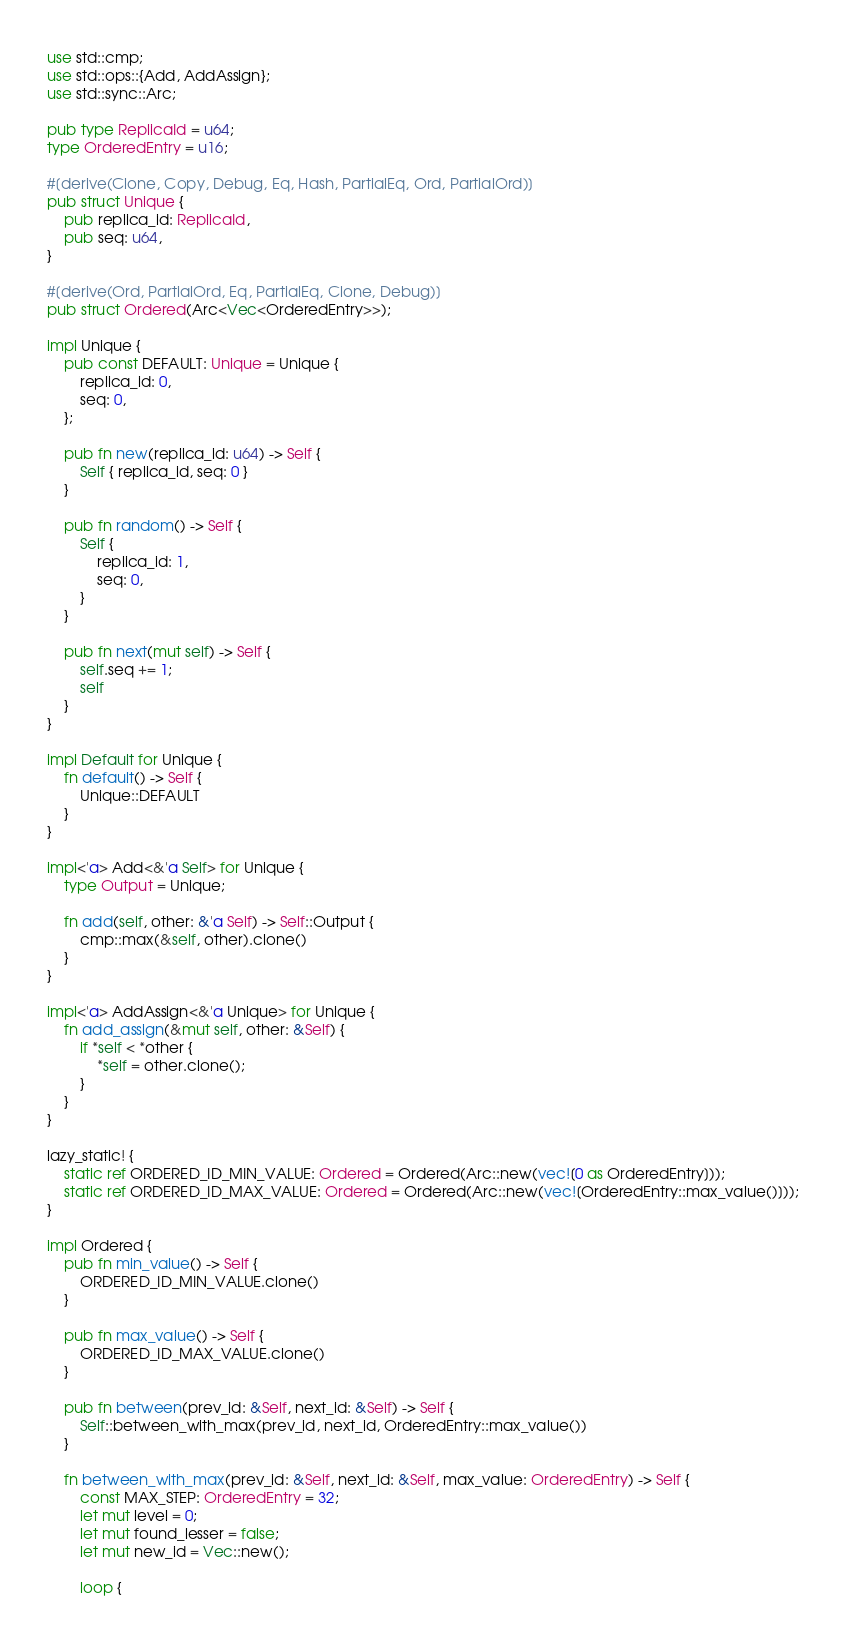<code> <loc_0><loc_0><loc_500><loc_500><_Rust_>use std::cmp;
use std::ops::{Add, AddAssign};
use std::sync::Arc;

pub type ReplicaId = u64;
type OrderedEntry = u16;

#[derive(Clone, Copy, Debug, Eq, Hash, PartialEq, Ord, PartialOrd)]
pub struct Unique {
    pub replica_id: ReplicaId,
    pub seq: u64,
}

#[derive(Ord, PartialOrd, Eq, PartialEq, Clone, Debug)]
pub struct Ordered(Arc<Vec<OrderedEntry>>);

impl Unique {
    pub const DEFAULT: Unique = Unique {
        replica_id: 0,
        seq: 0,
    };

    pub fn new(replica_id: u64) -> Self {
        Self { replica_id, seq: 0 }
    }

    pub fn random() -> Self {
        Self {
            replica_id: 1,
            seq: 0,
        }
    }

    pub fn next(mut self) -> Self {
        self.seq += 1;
        self
    }
}

impl Default for Unique {
    fn default() -> Self {
        Unique::DEFAULT
    }
}

impl<'a> Add<&'a Self> for Unique {
    type Output = Unique;

    fn add(self, other: &'a Self) -> Self::Output {
        cmp::max(&self, other).clone()
    }
}

impl<'a> AddAssign<&'a Unique> for Unique {
    fn add_assign(&mut self, other: &Self) {
        if *self < *other {
            *self = other.clone();
        }
    }
}

lazy_static! {
    static ref ORDERED_ID_MIN_VALUE: Ordered = Ordered(Arc::new(vec![0 as OrderedEntry]));
    static ref ORDERED_ID_MAX_VALUE: Ordered = Ordered(Arc::new(vec![OrderedEntry::max_value()]));
}

impl Ordered {
    pub fn min_value() -> Self {
        ORDERED_ID_MIN_VALUE.clone()
    }

    pub fn max_value() -> Self {
        ORDERED_ID_MAX_VALUE.clone()
    }

    pub fn between(prev_id: &Self, next_id: &Self) -> Self {
        Self::between_with_max(prev_id, next_id, OrderedEntry::max_value())
    }

    fn between_with_max(prev_id: &Self, next_id: &Self, max_value: OrderedEntry) -> Self {
        const MAX_STEP: OrderedEntry = 32;
        let mut level = 0;
        let mut found_lesser = false;
        let mut new_id = Vec::new();

        loop {</code> 